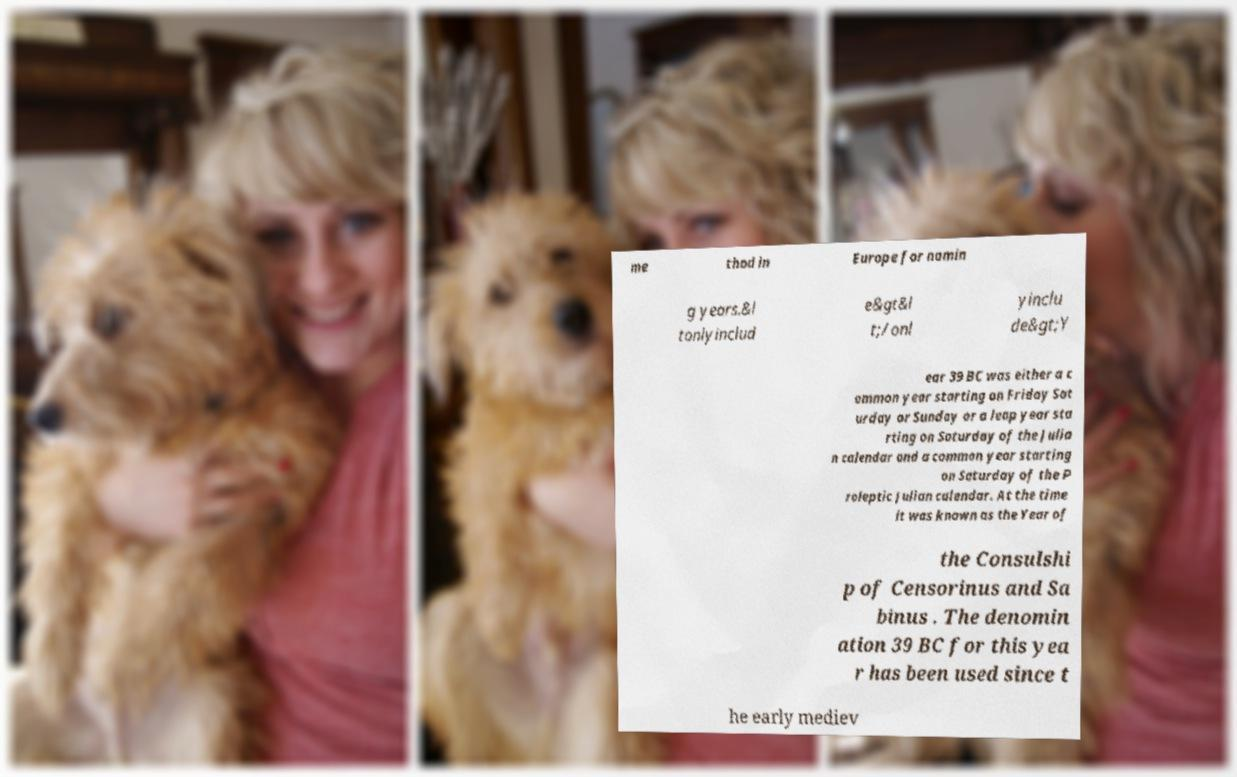Please read and relay the text visible in this image. What does it say? me thod in Europe for namin g years.&l tonlyinclud e&gt&l t;/onl yinclu de&gt;Y ear 39 BC was either a c ommon year starting on Friday Sat urday or Sunday or a leap year sta rting on Saturday of the Julia n calendar and a common year starting on Saturday of the P roleptic Julian calendar. At the time it was known as the Year of the Consulshi p of Censorinus and Sa binus . The denomin ation 39 BC for this yea r has been used since t he early mediev 